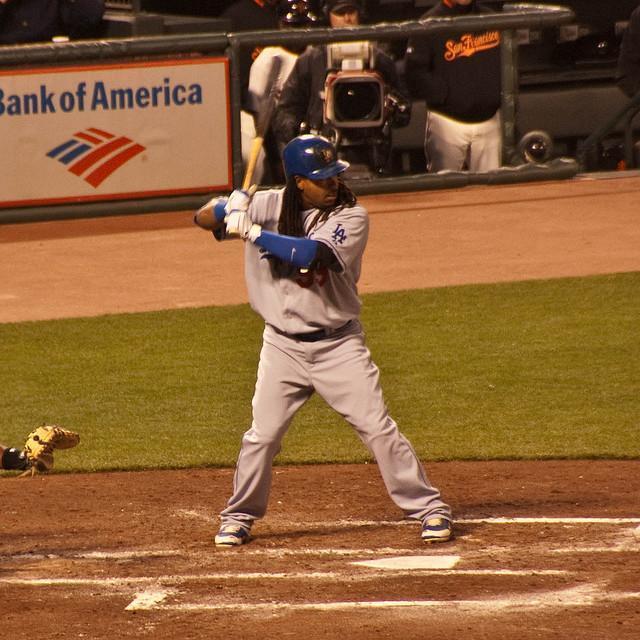How many people are in the photo?
Give a very brief answer. 5. How many giraffes have visible legs?
Give a very brief answer. 0. 